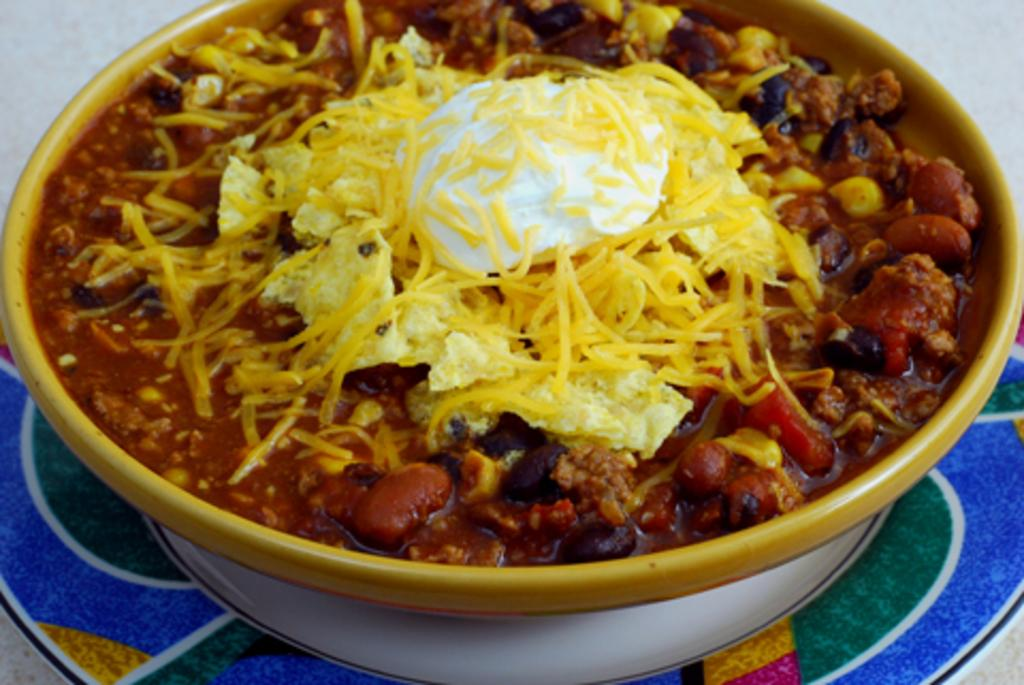What is in the bowl that is visible in the image? The bowl contains a food item. How is the bowl positioned in the image? The bowl is placed on a saucer. What color is the background of the image? The background of the image is white. What is the opinion of the hair in the image? There is no hair present in the image, so it is not possible to determine an opinion about it. 